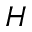<formula> <loc_0><loc_0><loc_500><loc_500>H</formula> 